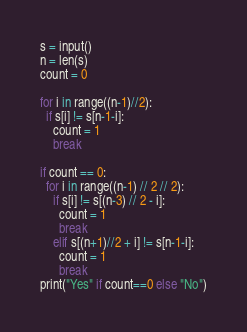Convert code to text. <code><loc_0><loc_0><loc_500><loc_500><_Python_>s = input()
n = len(s)
count = 0

for i in range((n-1)//2):
  if s[i] != s[n-1-i]:
    count = 1
    break

if count == 0:
  for i in range((n-1) // 2 // 2):
    if s[i] != s[(n-3) // 2 - i]:
      count = 1
      break
    elif s[(n+1)//2 + i] != s[n-1-i]:
      count = 1
      break
print("Yes" if count==0 else "No")</code> 